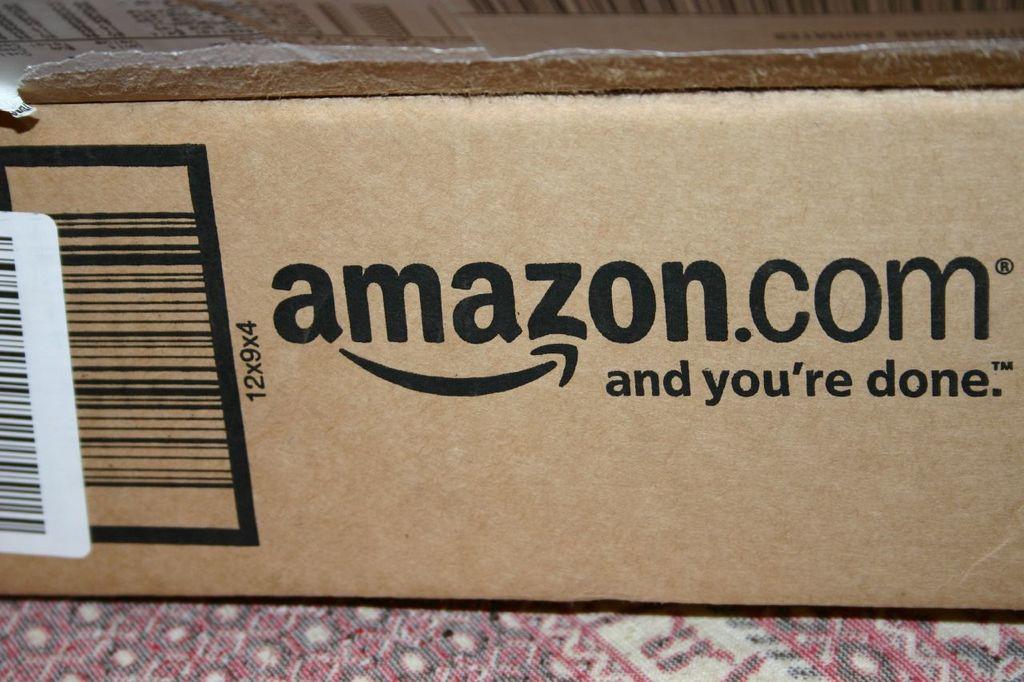Where did this box come from?
Ensure brevity in your answer.  Amazon. What logo is below the company name?
Offer a terse response. Amazon. 